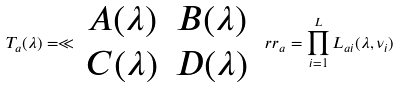Convert formula to latex. <formula><loc_0><loc_0><loc_500><loc_500>T _ { a } ( \lambda ) = \ll \begin{array} { c c } A ( \lambda ) & B ( \lambda ) \\ C ( \lambda ) & D ( \lambda ) \end{array} \ r r _ { a } = \prod _ { i = 1 } ^ { L } L _ { a i } ( \lambda , \nu _ { i } )</formula> 